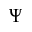Convert formula to latex. <formula><loc_0><loc_0><loc_500><loc_500>\Psi</formula> 